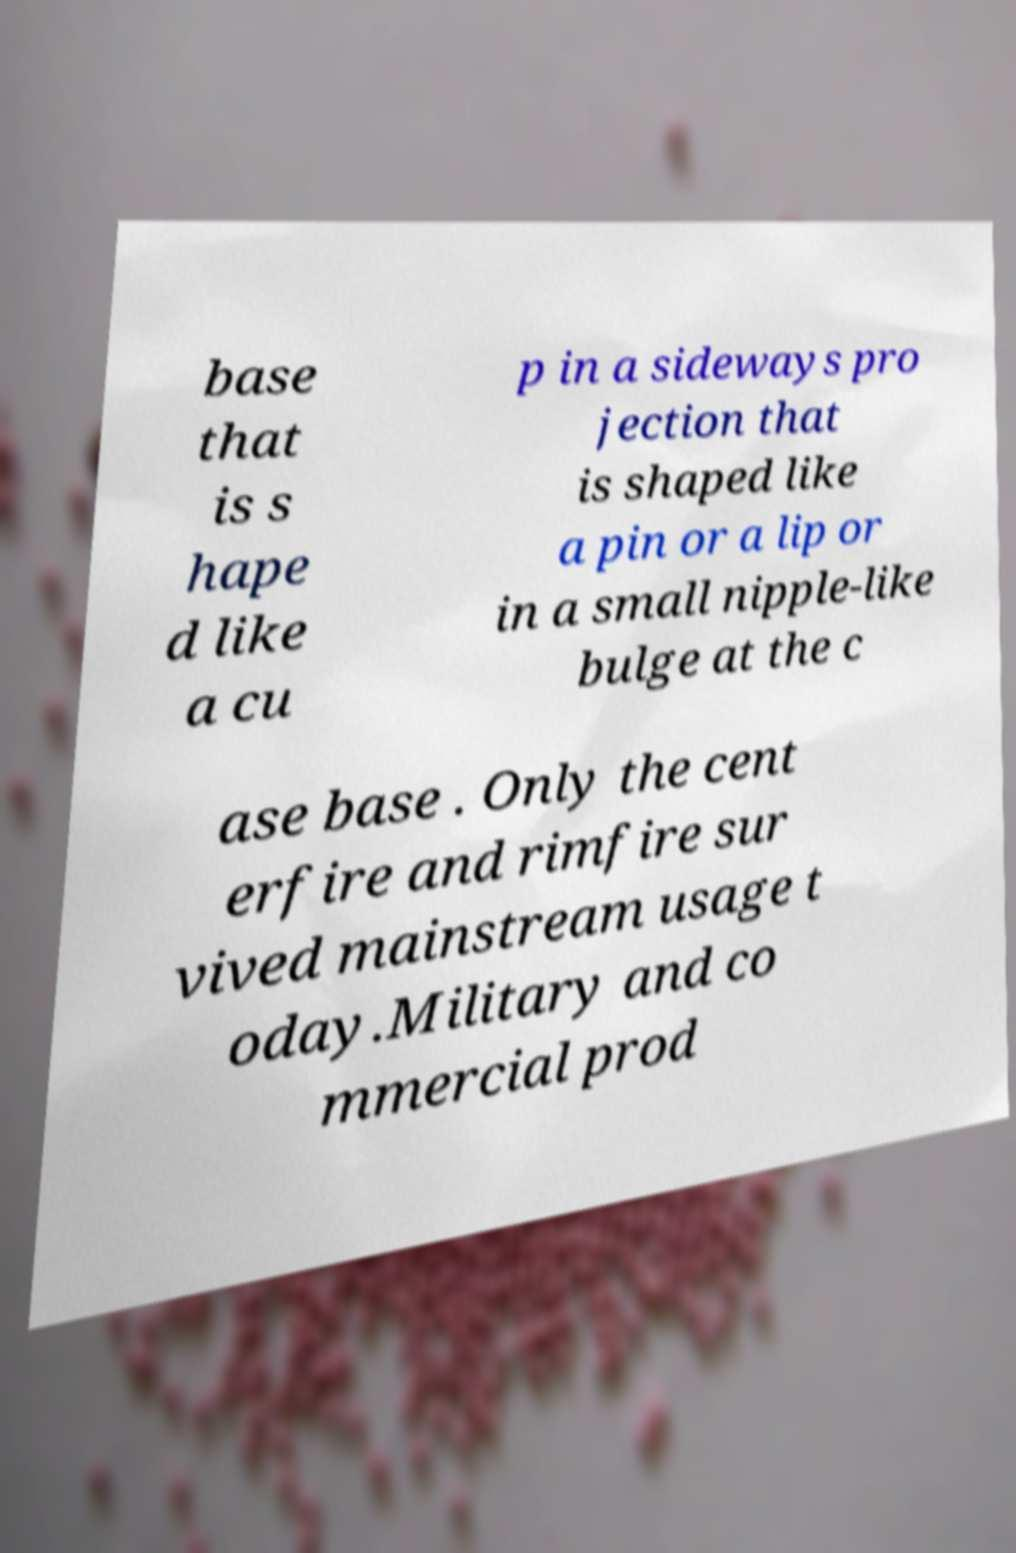Please read and relay the text visible in this image. What does it say? base that is s hape d like a cu p in a sideways pro jection that is shaped like a pin or a lip or in a small nipple-like bulge at the c ase base . Only the cent erfire and rimfire sur vived mainstream usage t oday.Military and co mmercial prod 